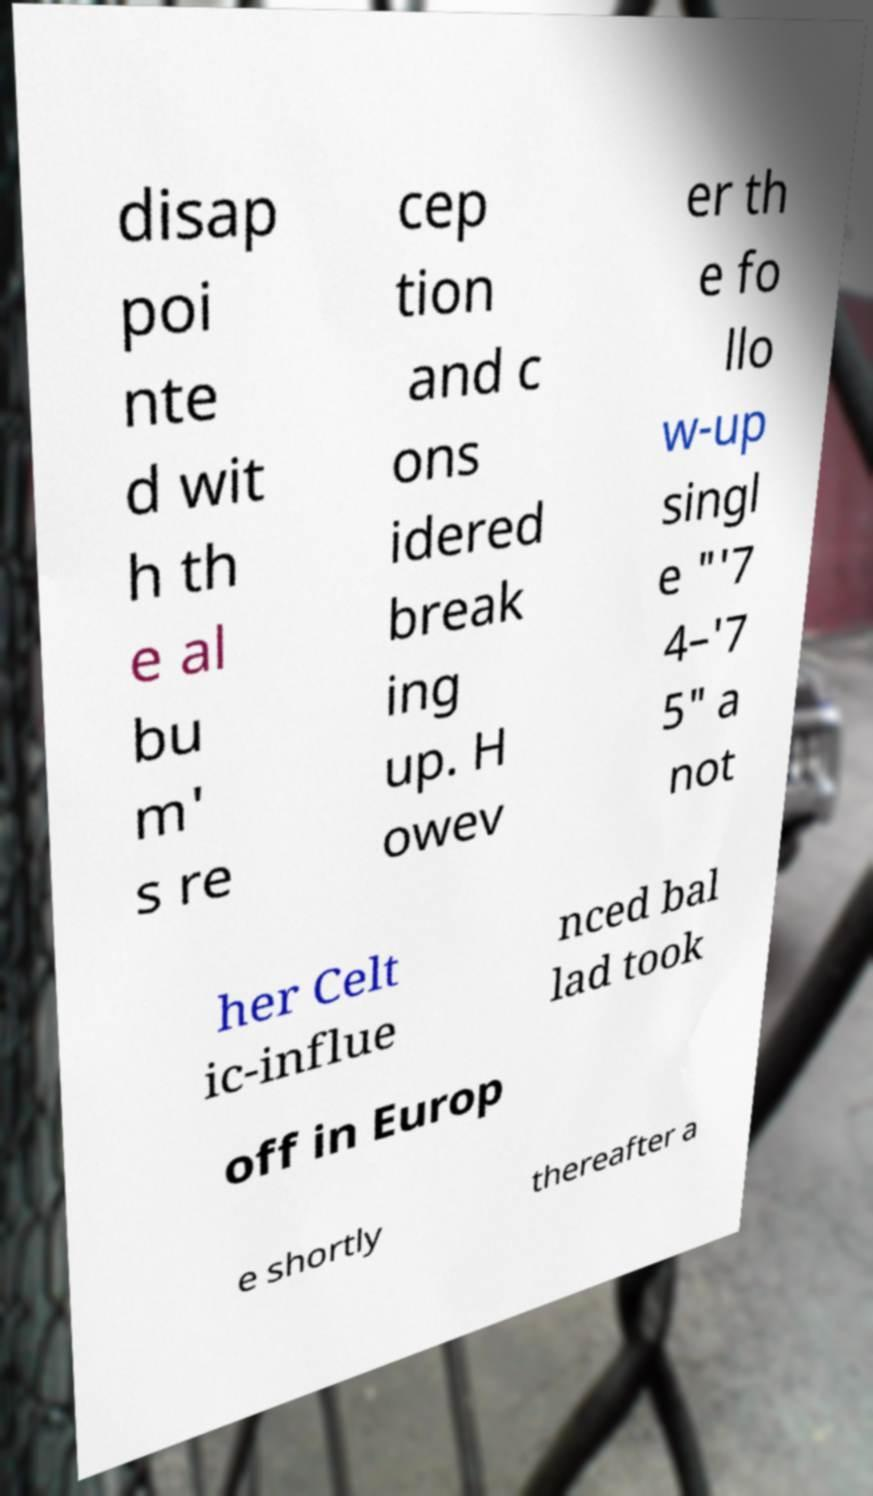Please identify and transcribe the text found in this image. disap poi nte d wit h th e al bu m' s re cep tion and c ons idered break ing up. H owev er th e fo llo w-up singl e "'7 4–'7 5" a not her Celt ic-influe nced bal lad took off in Europ e shortly thereafter a 